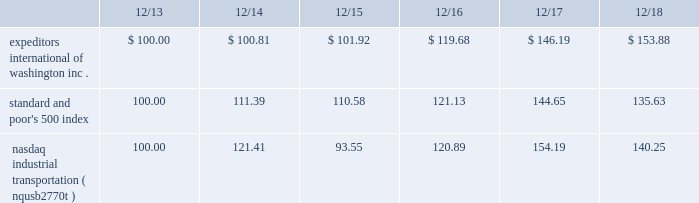The graph below compares expeditors international of washington , inc.'s cumulative 5-year total shareholder return on common stock with the cumulative total returns of the s&p 500 index and the nasdaq industrial transportation index ( nqusb2770t ) .
The graph assumes that the value of the investment in our common stock and in each of the indexes ( including reinvestment of dividends ) was $ 100 on 12/31/2013 and tracks it through 12/31/2018 .
Total return assumes reinvestment of dividends in each of the indices indicated .
Comparison of 5-year cumulative total return among expeditors international of washington , inc. , the s&p 500 index and the nasdaq industrial transportation index. .
The stock price performance included in this graph is not necessarily indicative of future stock price performance. .
What is the difference in percentage of cumulative total return between expeditors international of washington inc . and the nasdaq industrial transportation ( nqusb2770t ) for the 5 year period ending 12/18? 
Computations: (((153.88 - 100) / 100) - ((140.25 - 100) / 100))
Answer: 0.1363. 